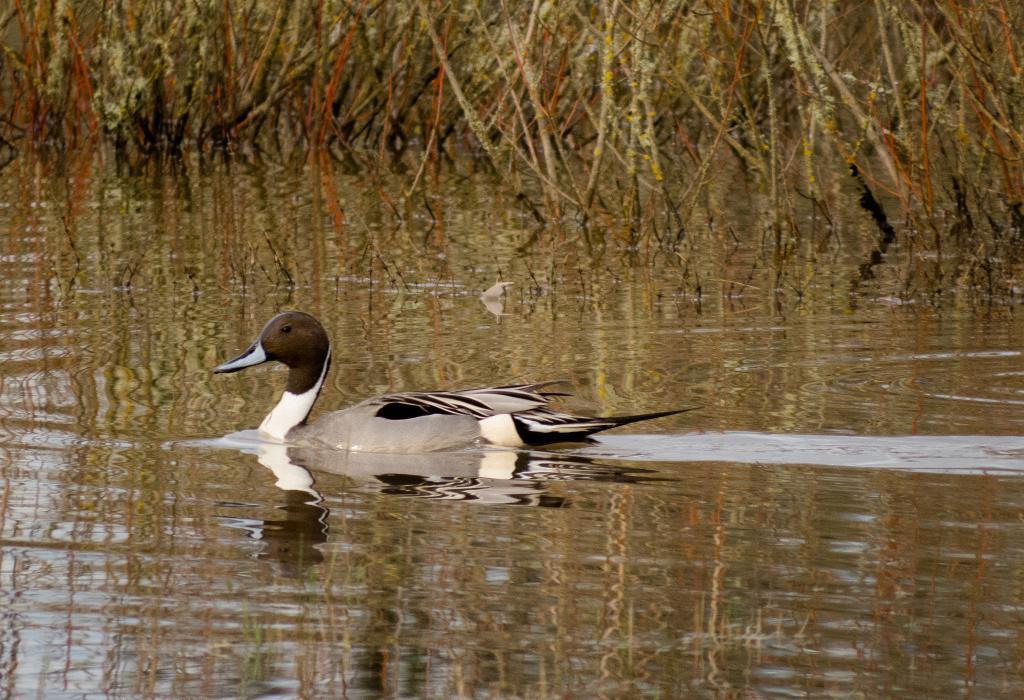In one or two sentences, can you explain what this image depicts? In this image, we can see a bird on the water. We can also see some plants. 